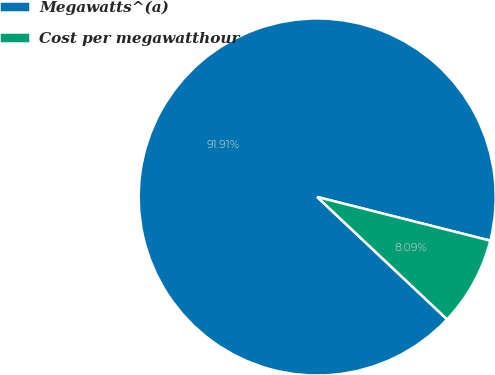Convert chart. <chart><loc_0><loc_0><loc_500><loc_500><pie_chart><fcel>Megawatts^(a)<fcel>Cost per megawatthour<nl><fcel>91.91%<fcel>8.09%<nl></chart> 